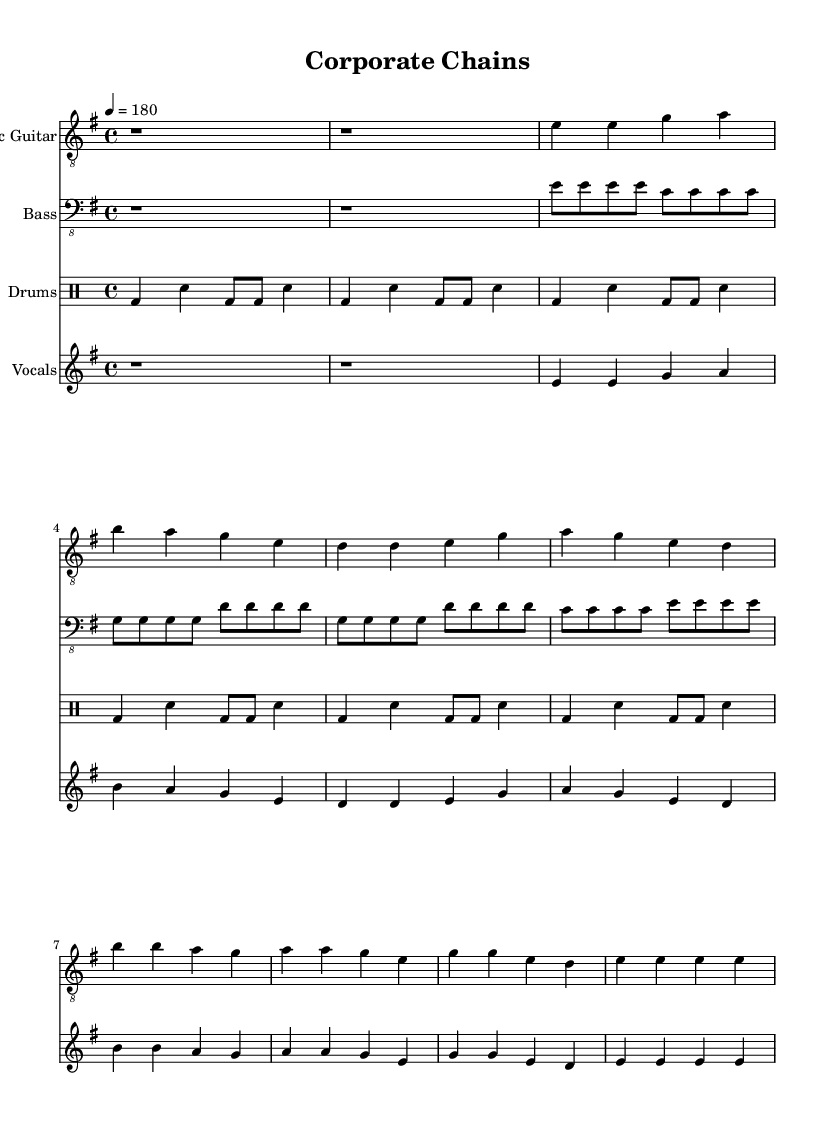what is the key signature of this music? The key signature is E minor, indicated by one sharp (F#). This is recognized by the key indicated in the global music block.
Answer: E minor what is the time signature of this music? The time signature is 4/4, meaning there are four beats in each measure, and each quarter note receives one beat. This is indicated at the start of the global music block.
Answer: 4/4 what is the tempo of this music? The tempo is marked at 180 beats per minute, indicating a fast pace. This is also shown in the global music block.
Answer: 180 how many measures are there in the chorus? The chorus consists of four measures, which can be counted from the notations given after the verse section.
Answer: 4 what instruments are featured in this sheet music? The instruments listed include Electric Guitar, Bass, Drums, and Vocals, as dictated by the different staff sections in the score.
Answer: Electric Guitar, Bass, Drums, Vocals what theme is being critiqued in the lyrics? The lyrics critique corporate culture and the constraints it imposes on individuals, as suggested by phrases like "Break the corporate chains." This reflects the punk ethos of rebellion against authority.
Answer: Corporate chains what rhythmic pattern does the drums follow in the intro? The drums follow a pattern of bass and snare hits, alternating between quarter and eighth notes, indicating a simple yet effective punk rhythm typical in the genre.
Answer: Bass and snare alternation 